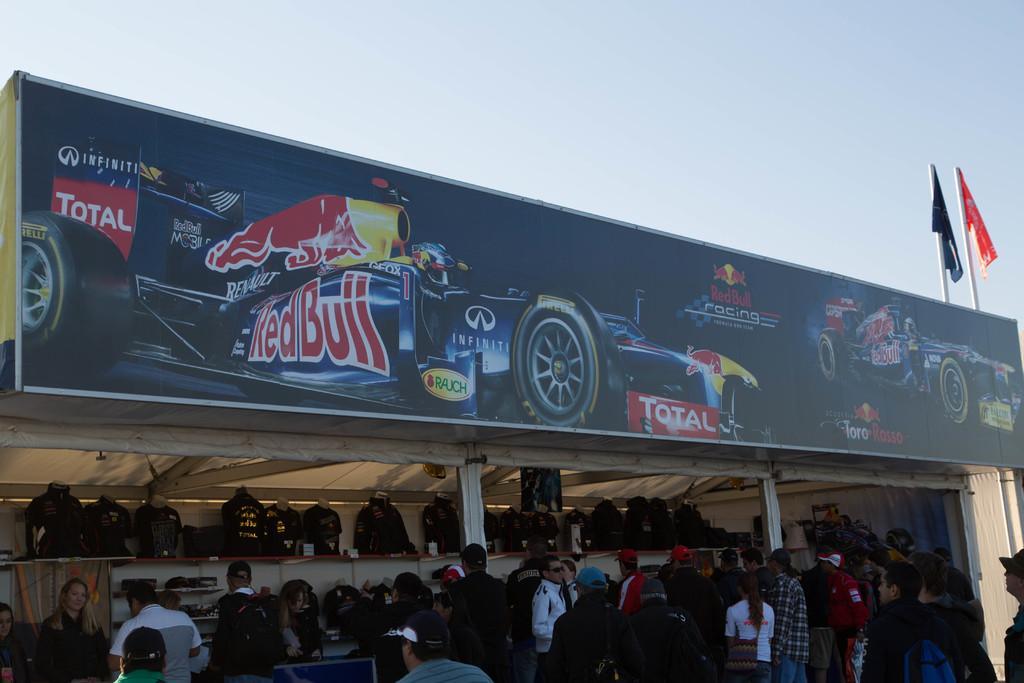Can you describe this image briefly? In this image we can see sky, flags, flag posts, advertisement board, mannequins and persons standing on the floor. 